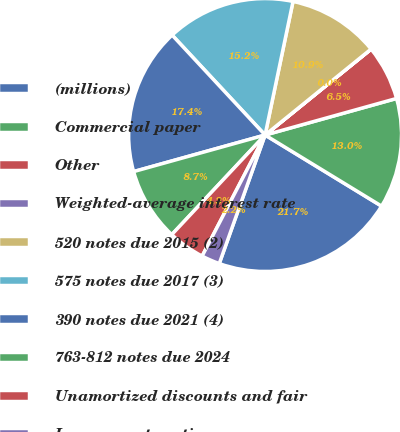Convert chart to OTSL. <chart><loc_0><loc_0><loc_500><loc_500><pie_chart><fcel>(millions)<fcel>Commercial paper<fcel>Other<fcel>Weighted-average interest rate<fcel>520 notes due 2015 (2)<fcel>575 notes due 2017 (3)<fcel>390 notes due 2021 (4)<fcel>763-812 notes due 2024<fcel>Unamortized discounts and fair<fcel>Less current portion<nl><fcel>21.73%<fcel>13.04%<fcel>6.52%<fcel>0.01%<fcel>10.87%<fcel>15.21%<fcel>17.39%<fcel>8.7%<fcel>4.35%<fcel>2.18%<nl></chart> 